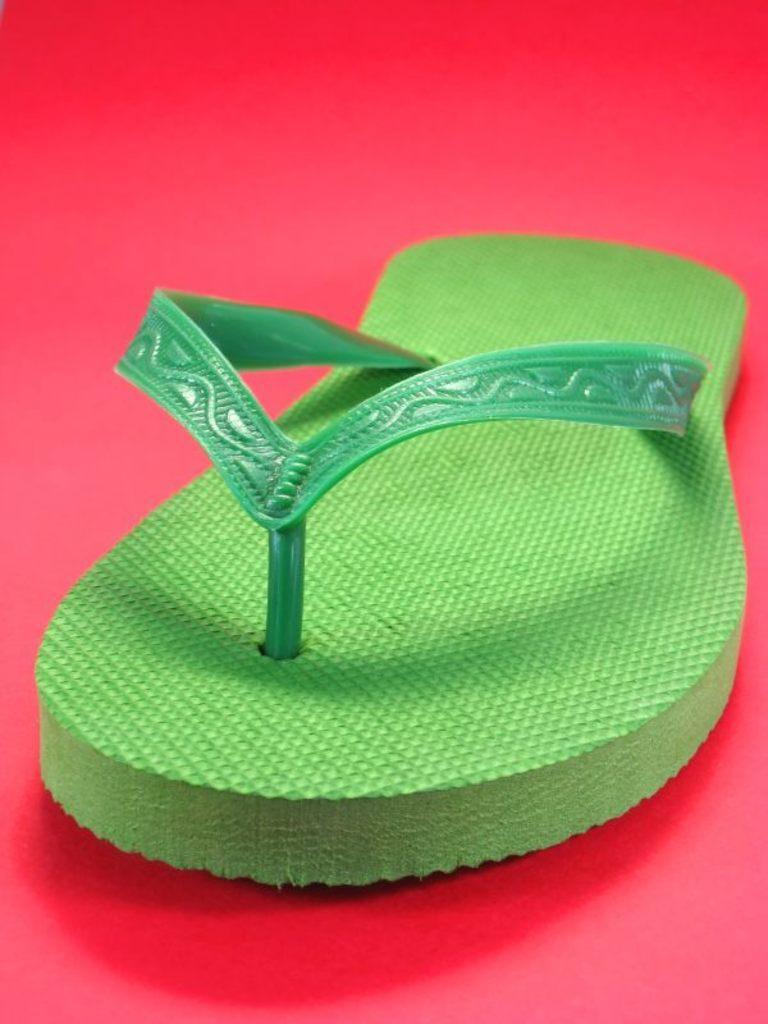Can you describe this image briefly? In the center of the image we can see one red carpet. On the carpet,we can see one footwear,which is in green color. 